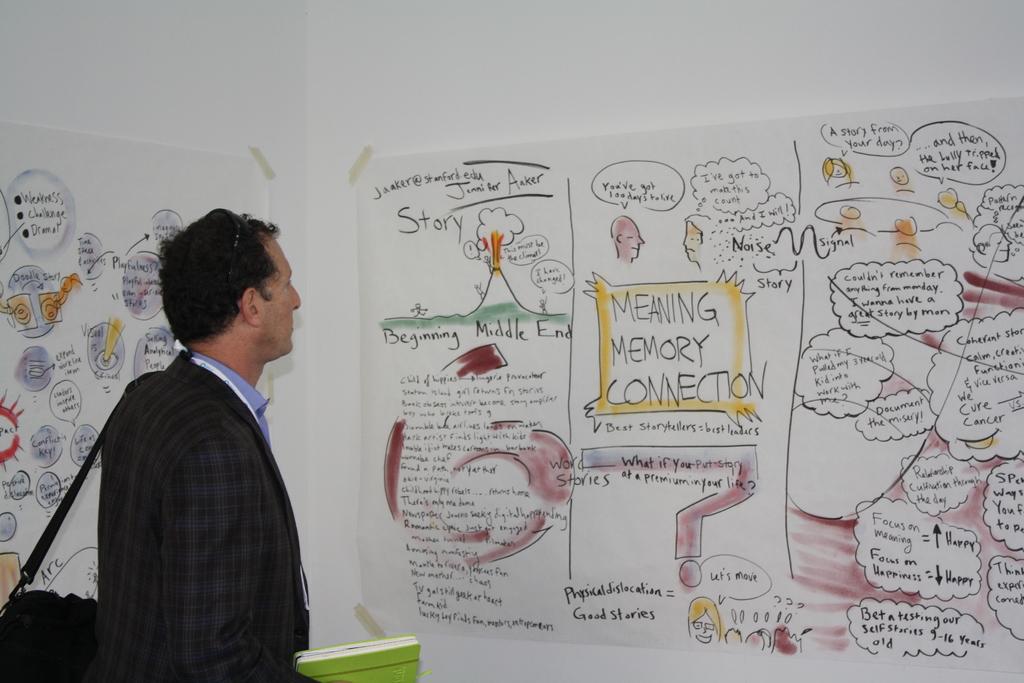What kind of connection is being discussed?
Your answer should be compact. Meaning memory. What is the email shown on the left?
Keep it short and to the point. Unanswerable. 